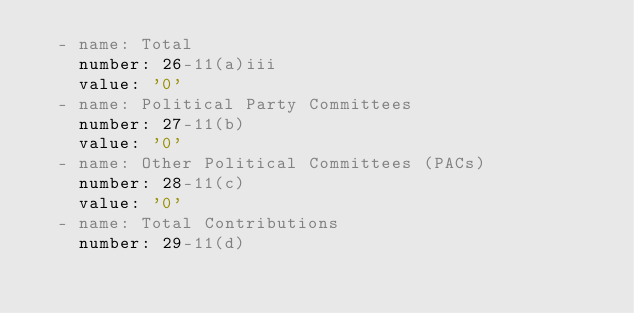Convert code to text. <code><loc_0><loc_0><loc_500><loc_500><_YAML_>  - name: Total
    number: 26-11(a)iii
    value: '0'
  - name: Political Party Committees
    number: 27-11(b)
    value: '0'
  - name: Other Political Committees (PACs)
    number: 28-11(c)
    value: '0'
  - name: Total Contributions
    number: 29-11(d)</code> 